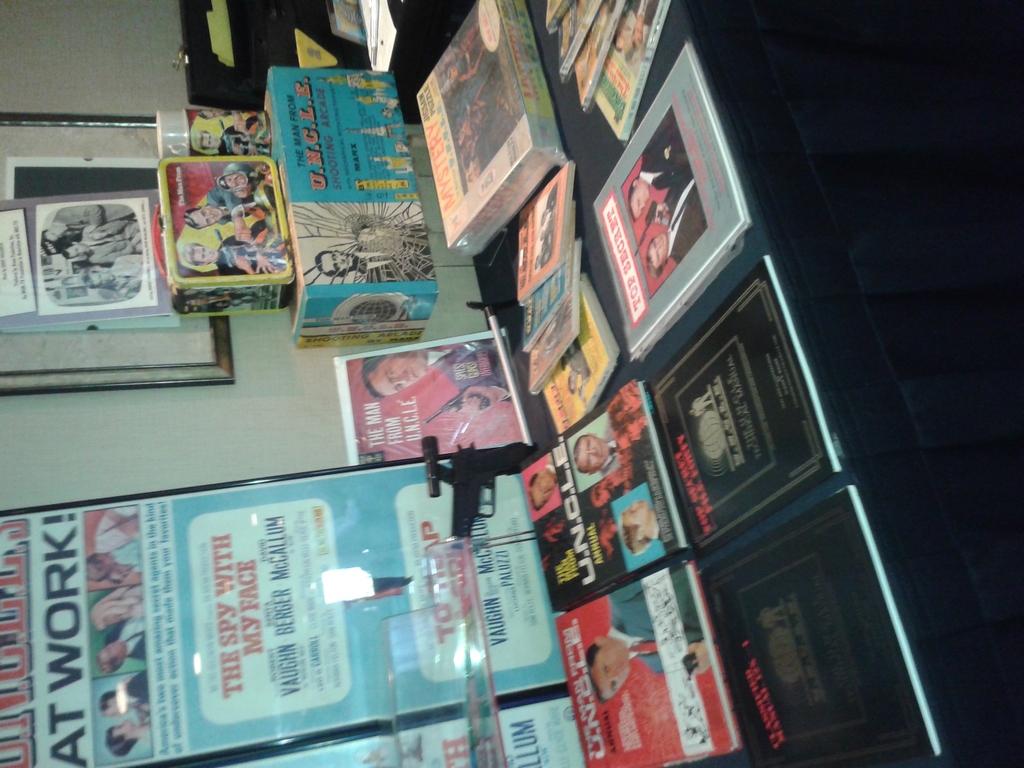What does the sign say in big letters with the exclamation?
Give a very brief answer. At work!. What show is the red magazine about?
Your answer should be compact. Unanswerable. 